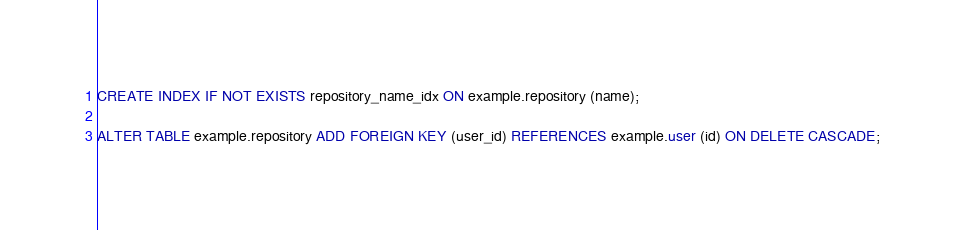<code> <loc_0><loc_0><loc_500><loc_500><_SQL_>CREATE INDEX IF NOT EXISTS repository_name_idx ON example.repository (name);

ALTER TABLE example.repository ADD FOREIGN KEY (user_id) REFERENCES example.user (id) ON DELETE CASCADE;
</code> 